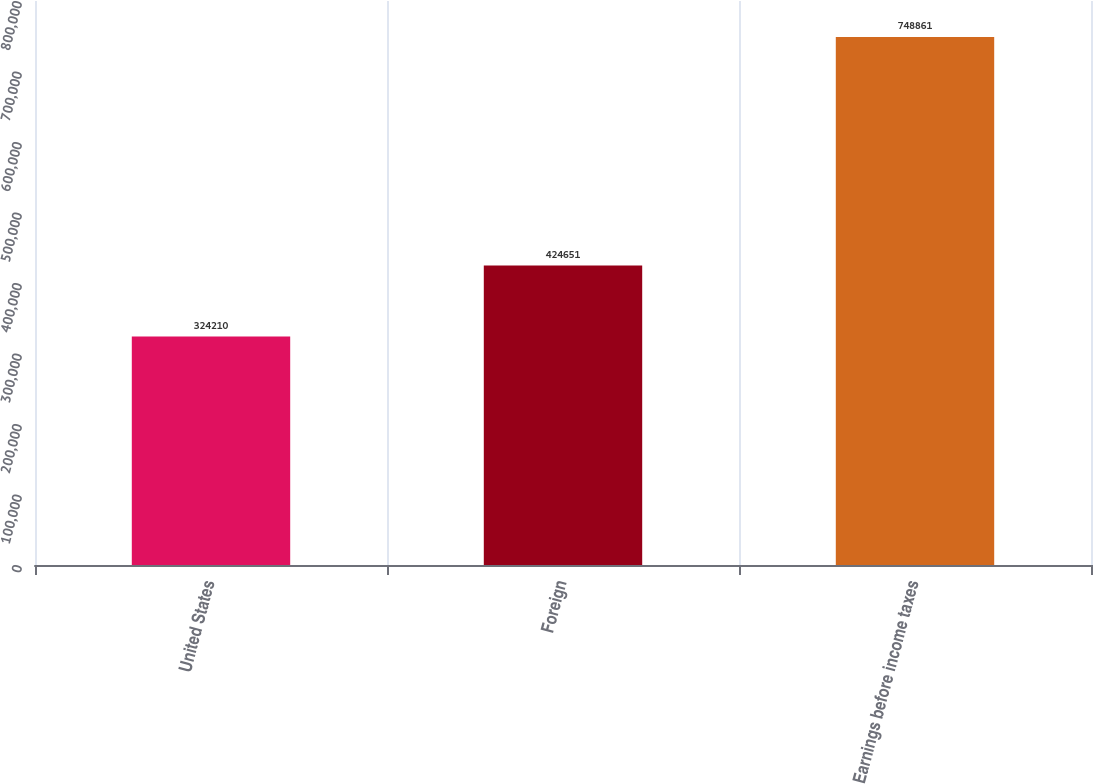Convert chart to OTSL. <chart><loc_0><loc_0><loc_500><loc_500><bar_chart><fcel>United States<fcel>Foreign<fcel>Earnings before income taxes<nl><fcel>324210<fcel>424651<fcel>748861<nl></chart> 